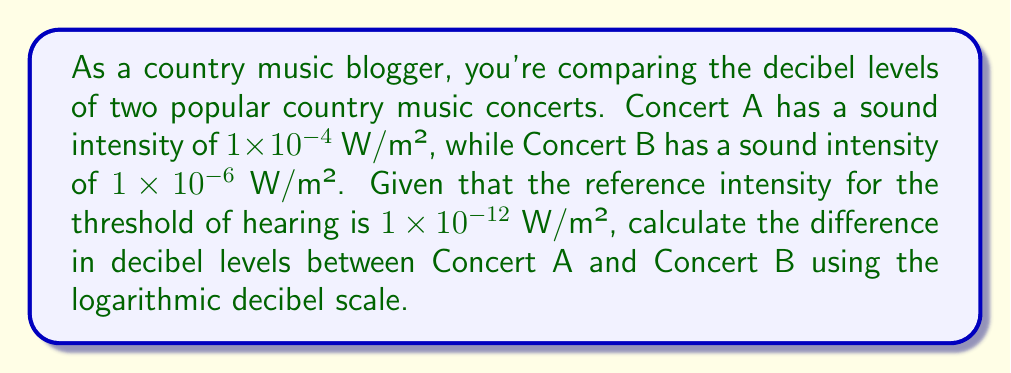Solve this math problem. To solve this problem, we'll use the formula for sound intensity level in decibels:

$$ L = 10 \log_{10}\left(\frac{I}{I_0}\right) $$

Where:
$L$ is the sound intensity level in decibels (dB)
$I$ is the sound intensity in W/m²
$I_0$ is the reference intensity ($1 \times 10^{-12}$ W/m²)

Step 1: Calculate the decibel level for Concert A
$$ L_A = 10 \log_{10}\left(\frac{1 \times 10^{-4}}{1 \times 10^{-12}}\right) = 10 \log_{10}(10^8) = 10 \times 8 = 80 \text{ dB} $$

Step 2: Calculate the decibel level for Concert B
$$ L_B = 10 \log_{10}\left(\frac{1 \times 10^{-6}}{1 \times 10^{-12}}\right) = 10 \log_{10}(10^6) = 10 \times 6 = 60 \text{ dB} $$

Step 3: Calculate the difference in decibel levels
$$ \text{Difference} = L_A - L_B = 80 \text{ dB} - 60 \text{ dB} = 20 \text{ dB} $$
Answer: The difference in decibel levels between Concert A and Concert B is 20 dB. 